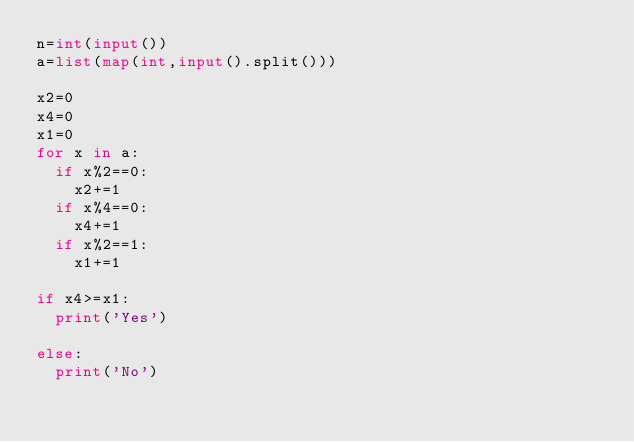<code> <loc_0><loc_0><loc_500><loc_500><_Python_>n=int(input())
a=list(map(int,input().split()))

x2=0
x4=0
x1=0
for x in a:
  if x%2==0:
    x2+=1
  if x%4==0:
    x4+=1
  if x%2==1:
    x1+=1
    
if x4>=x1:
  print('Yes')
  
else:
  print('No')
  </code> 